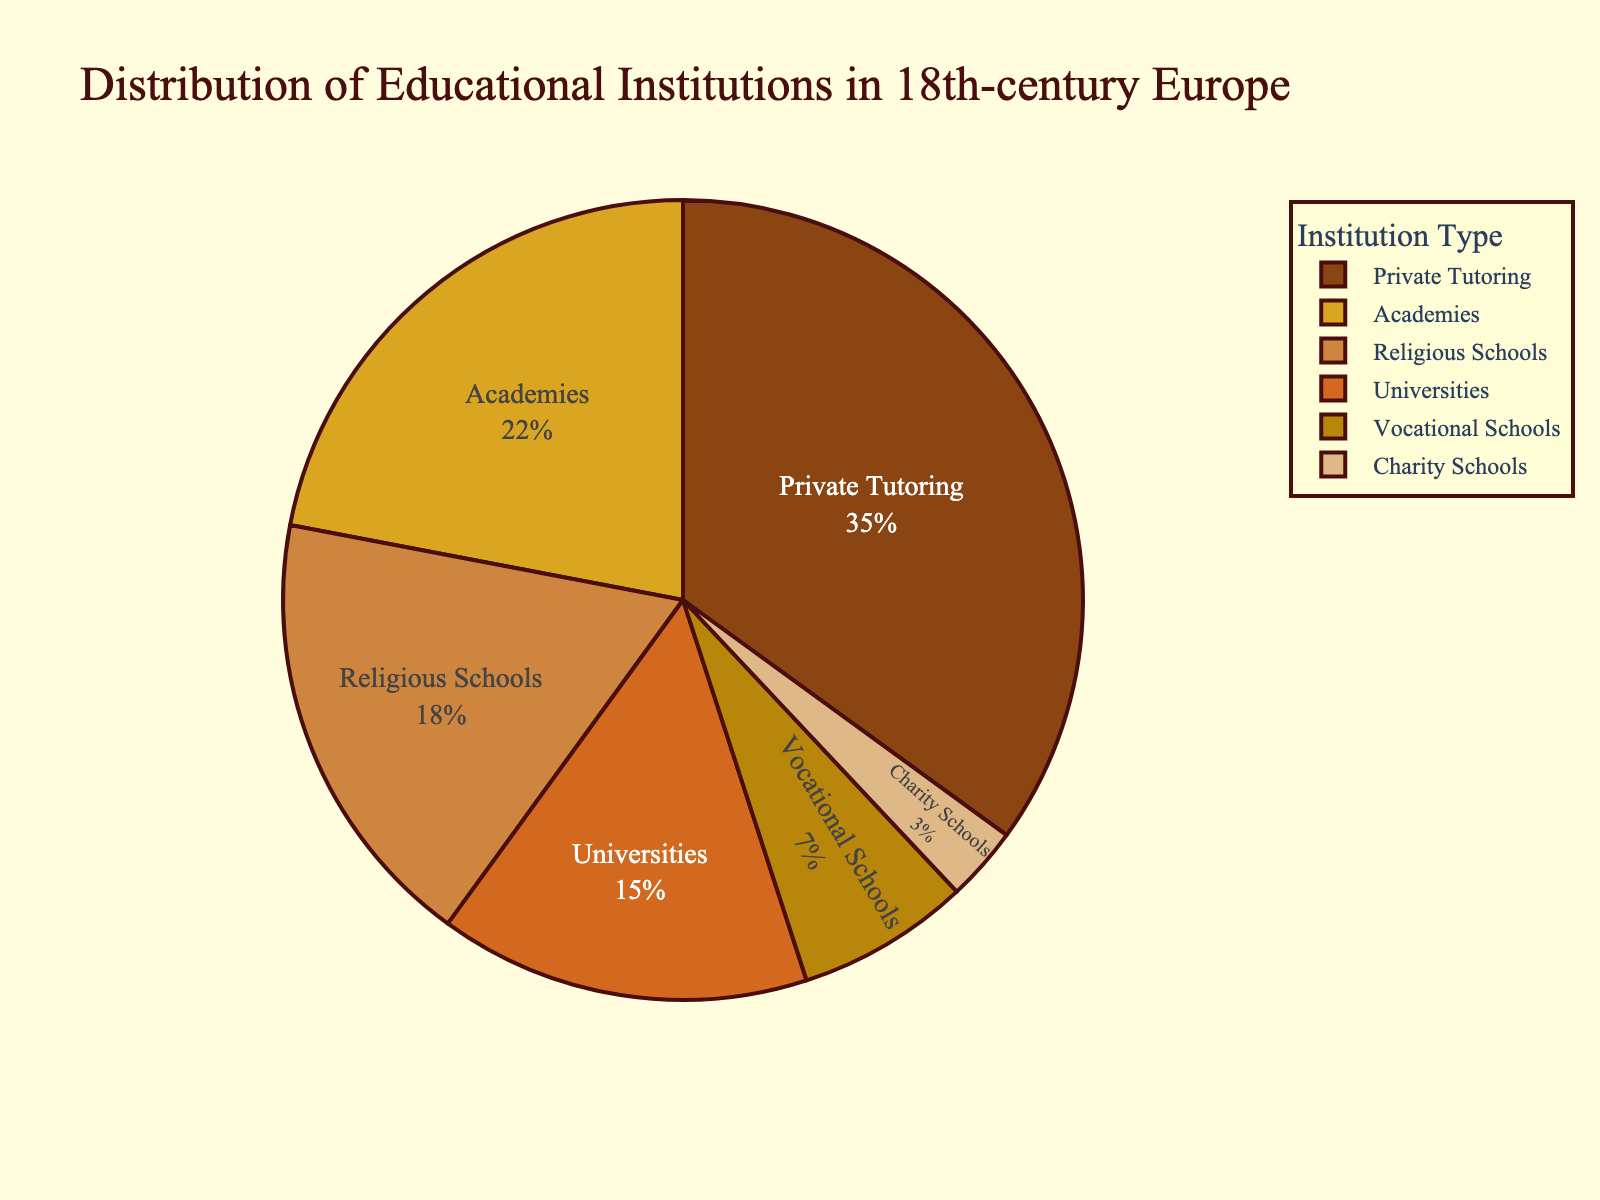What's the most common type of educational institution in 18th-century Europe? The pie chart shows percentage distributions; the largest slice represents the most common type. Private Tutoring has the largest slice at 35%.
Answer: Private Tutoring What percentage of institutions are Academies and Vocational Schools combined? Add the percentages for Academies (22%) and Vocational Schools (7%): 22 + 7 = 29.
Answer: 29% Are there more Religious Schools or Academies? Compare the percentages: Religious Schools (18%) vs. Academies (22%).
Answer: Academies Which type of institution is represented by the darkest color? Visually identify the darkest color in the pie chart. The darkest slice corresponds to Universities.
Answer: Universities What is the difference in percentage between Private Tutoring and Universities? Subtract the percentage of Universities (15%) from Private Tutoring (35%): 35 - 15 = 20.
Answer: 20% What proportion of institutions are not Private Tutoring? Subtract the percentage of Private Tutoring (35%) from 100%: 100 - 35 = 65.
Answer: 65% How many types of institutions have a higher percentage than Religious Schools? Compare each type's percentage against Religious Schools (18%): Private Tutoring (35%) and Academies (22%) are higher.
Answer: 2 Which types of institutions account for exactly 40% combined? Check various combinations: Universities (15%) + Religious Schools (18%) + Charity Schools (3%) = 36%, or Academies (22%) + Vocational Schools (7%) + Charity Schools (3%) = 32%. Only Universities (15%) + Academies (22%) + Charity Schools (3%) = 40%.
Answer: Universities, Academies, and Charity Schools What visual attribute is shared by the segments representing Vocational Schools and Charity Schools? Both segments are distinguished by their relatively smaller slices in the pie chart compared to others.
Answer: Small slice size If Charity Schools doubled their percentage, what would their new percentage be? Double the initial percentage of Charity Schools (3%): 3 x 2 = 6.
Answer: 6% 